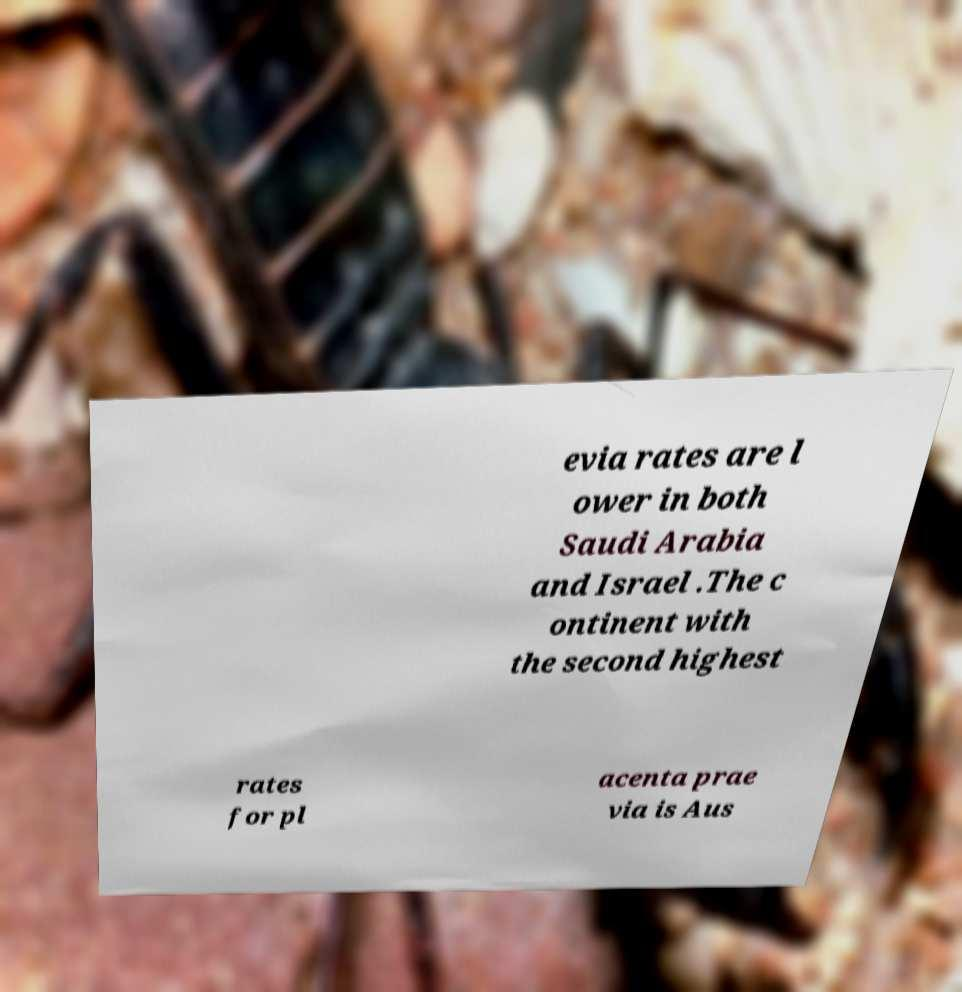Please read and relay the text visible in this image. What does it say? evia rates are l ower in both Saudi Arabia and Israel .The c ontinent with the second highest rates for pl acenta prae via is Aus 